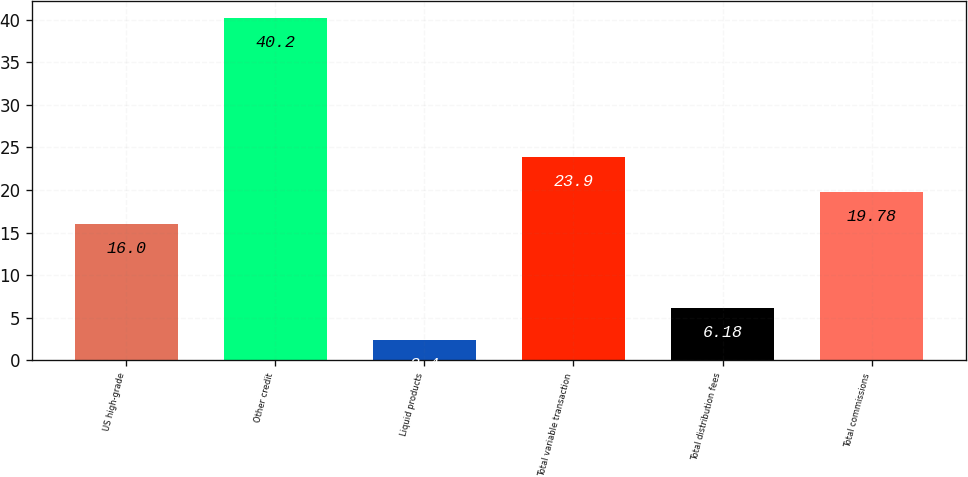Convert chart to OTSL. <chart><loc_0><loc_0><loc_500><loc_500><bar_chart><fcel>US high-grade<fcel>Other credit<fcel>Liquid products<fcel>Total variable transaction<fcel>Total distribution fees<fcel>Total commissions<nl><fcel>16<fcel>40.2<fcel>2.4<fcel>23.9<fcel>6.18<fcel>19.78<nl></chart> 